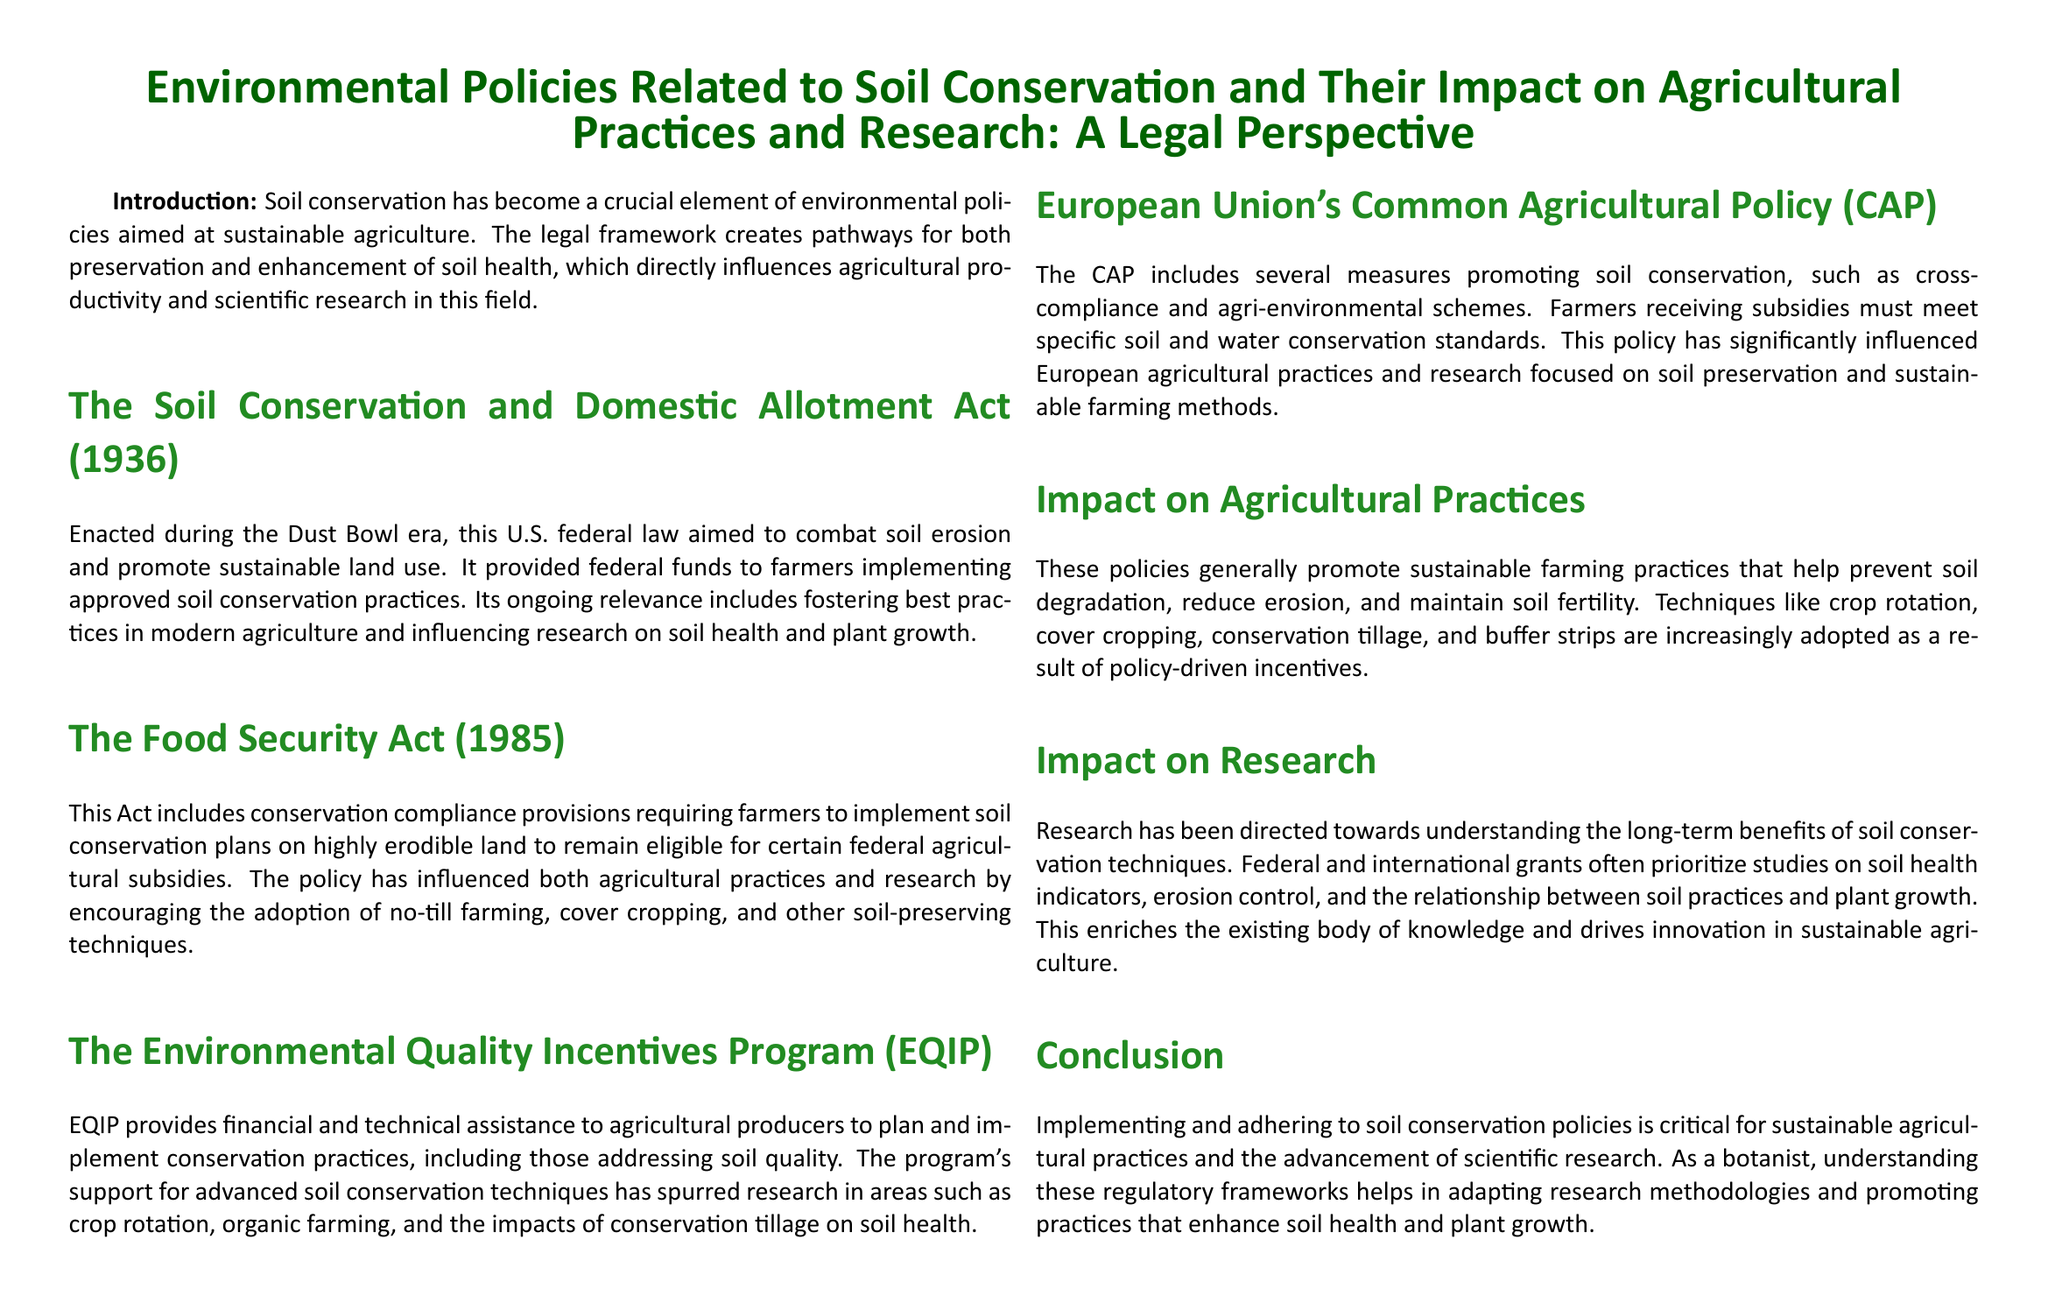What is the title of the document? The title provides the main topic covered in the legal brief.
Answer: Environmental Policies Related to Soil Conservation and Their Impact on Agricultural Practices and Research: A Legal Perspective When was the Soil Conservation and Domestic Allotment Act enacted? The specific date mentioned indicates when the law was established.
Answer: 1936 What does EQIP stand for? The abbreviation stands for a program aimed at assisting agricultural producers in conservation practices.
Answer: Environmental Quality Incentives Program What agricultural practice is encouraged by the Food Security Act? This policy focuses on a specific practice to remain eligible for federal subsidies.
Answer: Soil conservation plans What is a significant impact of these policies on agricultural practices? The document highlights how these policies influence farming techniques.
Answer: Sustainable farming practices How does the European Union's Common Agricultural Policy affect farmers? This section describes a requirement for farmers receiving subsidies.
Answer: Meet specific soil and water conservation standards What type of research is prioritized by federal and international grants? The document specifies the focus of studies incentivized by funding.
Answer: Soil health indicators What era was the Soil Conservation and Domestic Allotment Act associated with? The document references a notable historical period linked to the act.
Answer: Dust Bowl What conservation technique is mentioned that helps prevent soil degradation? The document lists practices adopted as a result of policy-driven incentives.
Answer: Crop rotation 